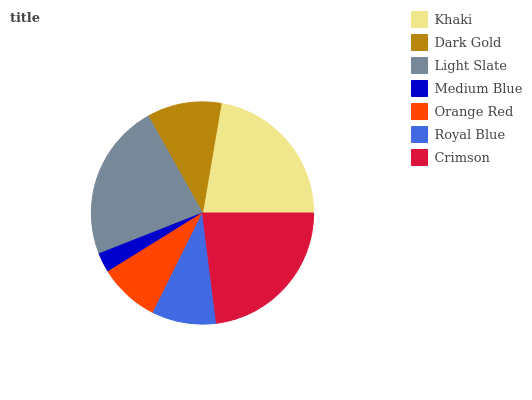Is Medium Blue the minimum?
Answer yes or no. Yes. Is Crimson the maximum?
Answer yes or no. Yes. Is Dark Gold the minimum?
Answer yes or no. No. Is Dark Gold the maximum?
Answer yes or no. No. Is Khaki greater than Dark Gold?
Answer yes or no. Yes. Is Dark Gold less than Khaki?
Answer yes or no. Yes. Is Dark Gold greater than Khaki?
Answer yes or no. No. Is Khaki less than Dark Gold?
Answer yes or no. No. Is Dark Gold the high median?
Answer yes or no. Yes. Is Dark Gold the low median?
Answer yes or no. Yes. Is Khaki the high median?
Answer yes or no. No. Is Orange Red the low median?
Answer yes or no. No. 